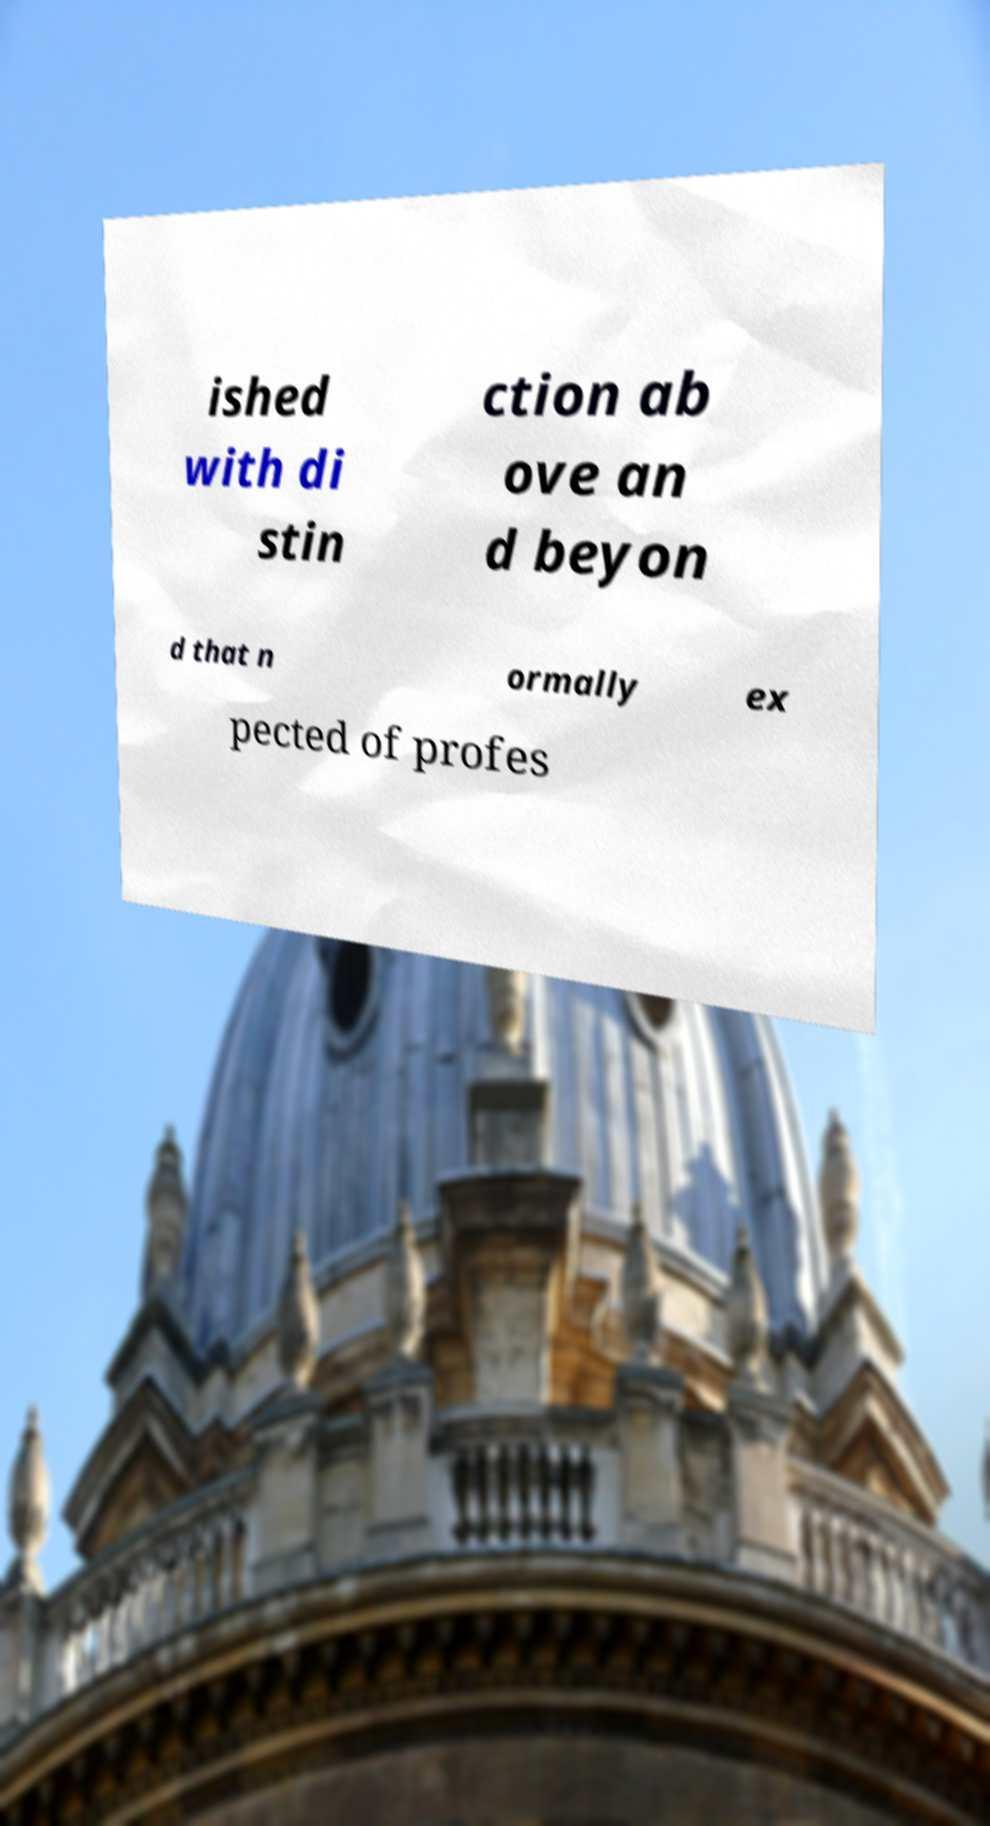Could you assist in decoding the text presented in this image and type it out clearly? ished with di stin ction ab ove an d beyon d that n ormally ex pected of profes 